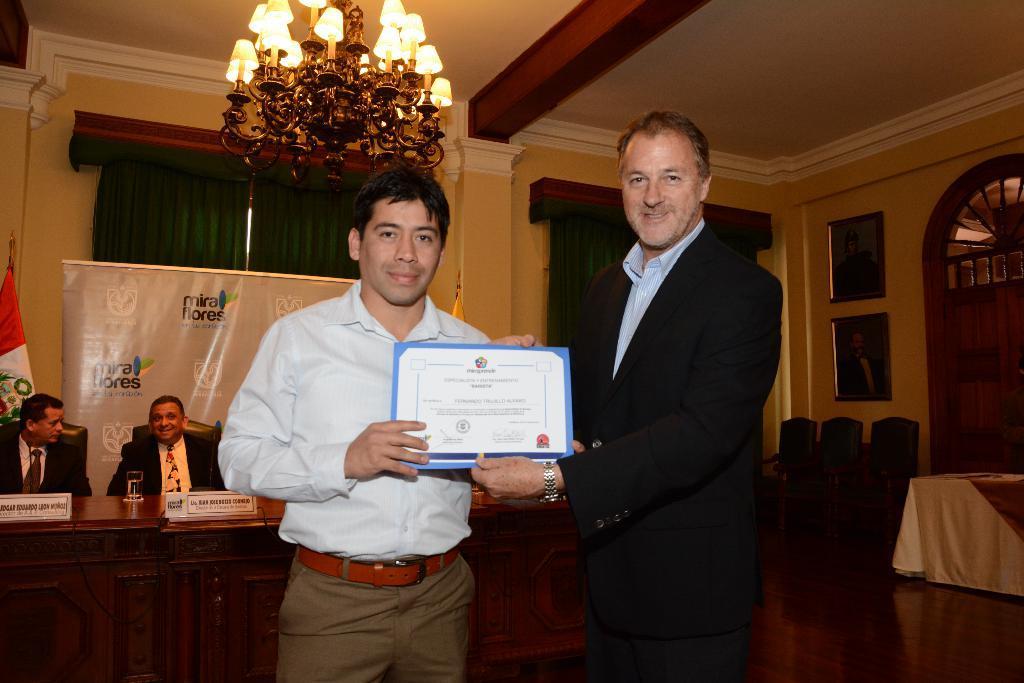Could you give a brief overview of what you see in this image? At the foreground of the image there are two persons who are posing for a photograph holding certificate in their hands and at the background of the image there are some persons sitting on the chairs. 